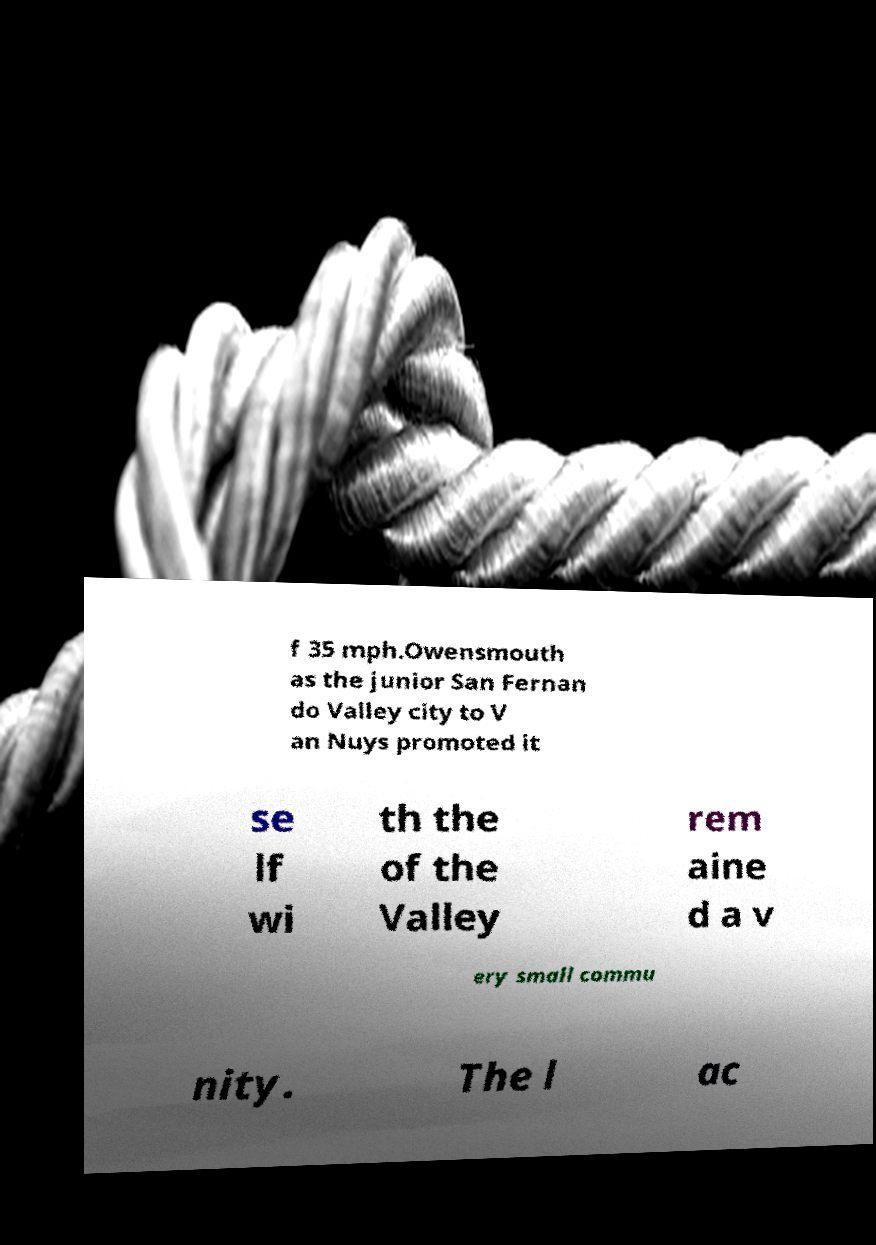Please identify and transcribe the text found in this image. f 35 mph.Owensmouth as the junior San Fernan do Valley city to V an Nuys promoted it se lf wi th the of the Valley rem aine d a v ery small commu nity. The l ac 